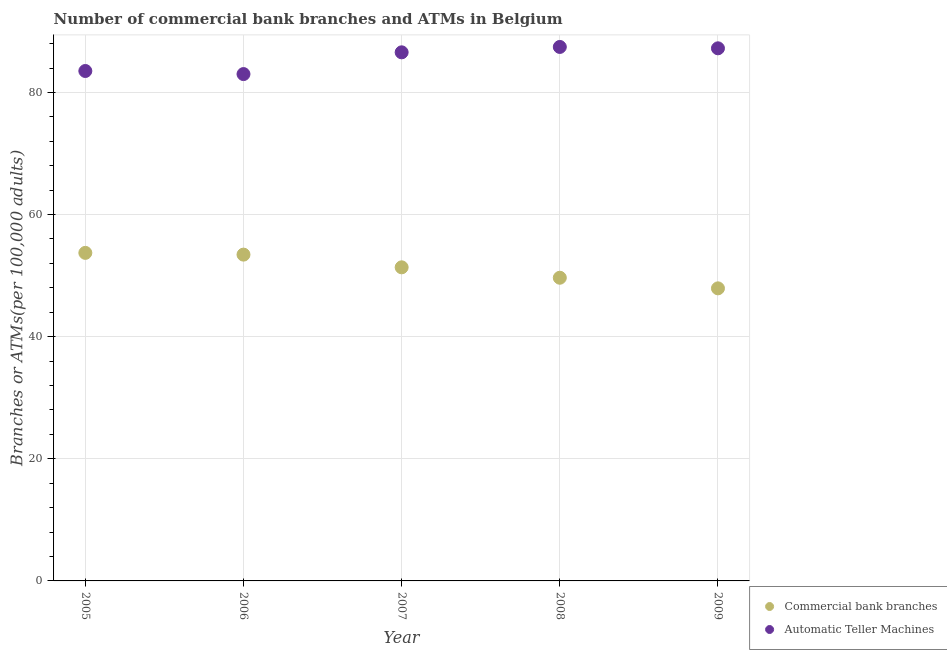How many different coloured dotlines are there?
Give a very brief answer. 2. Is the number of dotlines equal to the number of legend labels?
Your answer should be compact. Yes. What is the number of atms in 2005?
Offer a terse response. 83.51. Across all years, what is the maximum number of atms?
Your answer should be very brief. 87.45. Across all years, what is the minimum number of atms?
Your answer should be very brief. 83.01. In which year was the number of atms maximum?
Offer a terse response. 2008. In which year was the number of atms minimum?
Ensure brevity in your answer.  2006. What is the total number of atms in the graph?
Offer a very short reply. 427.77. What is the difference between the number of atms in 2006 and that in 2009?
Give a very brief answer. -4.22. What is the difference between the number of atms in 2009 and the number of commercal bank branches in 2008?
Give a very brief answer. 37.57. What is the average number of commercal bank branches per year?
Ensure brevity in your answer.  51.22. In the year 2008, what is the difference between the number of atms and number of commercal bank branches?
Provide a short and direct response. 37.8. In how many years, is the number of atms greater than 16?
Offer a terse response. 5. What is the ratio of the number of atms in 2005 to that in 2006?
Give a very brief answer. 1.01. Is the number of atms in 2006 less than that in 2009?
Give a very brief answer. Yes. Is the difference between the number of commercal bank branches in 2007 and 2008 greater than the difference between the number of atms in 2007 and 2008?
Provide a succinct answer. Yes. What is the difference between the highest and the second highest number of commercal bank branches?
Give a very brief answer. 0.29. What is the difference between the highest and the lowest number of commercal bank branches?
Your response must be concise. 5.81. In how many years, is the number of atms greater than the average number of atms taken over all years?
Provide a succinct answer. 3. Is the sum of the number of commercal bank branches in 2006 and 2007 greater than the maximum number of atms across all years?
Ensure brevity in your answer.  Yes. Is the number of atms strictly less than the number of commercal bank branches over the years?
Your answer should be very brief. No. How many dotlines are there?
Ensure brevity in your answer.  2. How many years are there in the graph?
Provide a succinct answer. 5. What is the difference between two consecutive major ticks on the Y-axis?
Provide a succinct answer. 20. Are the values on the major ticks of Y-axis written in scientific E-notation?
Offer a very short reply. No. Where does the legend appear in the graph?
Provide a short and direct response. Bottom right. How many legend labels are there?
Offer a terse response. 2. How are the legend labels stacked?
Your response must be concise. Vertical. What is the title of the graph?
Provide a succinct answer. Number of commercial bank branches and ATMs in Belgium. Does "Savings" appear as one of the legend labels in the graph?
Offer a terse response. No. What is the label or title of the Y-axis?
Your answer should be very brief. Branches or ATMs(per 100,0 adults). What is the Branches or ATMs(per 100,000 adults) of Commercial bank branches in 2005?
Your answer should be very brief. 53.73. What is the Branches or ATMs(per 100,000 adults) of Automatic Teller Machines in 2005?
Offer a very short reply. 83.51. What is the Branches or ATMs(per 100,000 adults) of Commercial bank branches in 2006?
Provide a short and direct response. 53.44. What is the Branches or ATMs(per 100,000 adults) in Automatic Teller Machines in 2006?
Keep it short and to the point. 83.01. What is the Branches or ATMs(per 100,000 adults) in Commercial bank branches in 2007?
Give a very brief answer. 51.36. What is the Branches or ATMs(per 100,000 adults) in Automatic Teller Machines in 2007?
Keep it short and to the point. 86.57. What is the Branches or ATMs(per 100,000 adults) in Commercial bank branches in 2008?
Ensure brevity in your answer.  49.65. What is the Branches or ATMs(per 100,000 adults) in Automatic Teller Machines in 2008?
Your answer should be compact. 87.45. What is the Branches or ATMs(per 100,000 adults) of Commercial bank branches in 2009?
Ensure brevity in your answer.  47.92. What is the Branches or ATMs(per 100,000 adults) in Automatic Teller Machines in 2009?
Offer a terse response. 87.23. Across all years, what is the maximum Branches or ATMs(per 100,000 adults) in Commercial bank branches?
Your answer should be compact. 53.73. Across all years, what is the maximum Branches or ATMs(per 100,000 adults) in Automatic Teller Machines?
Your response must be concise. 87.45. Across all years, what is the minimum Branches or ATMs(per 100,000 adults) in Commercial bank branches?
Ensure brevity in your answer.  47.92. Across all years, what is the minimum Branches or ATMs(per 100,000 adults) of Automatic Teller Machines?
Your answer should be compact. 83.01. What is the total Branches or ATMs(per 100,000 adults) in Commercial bank branches in the graph?
Offer a terse response. 256.1. What is the total Branches or ATMs(per 100,000 adults) of Automatic Teller Machines in the graph?
Your response must be concise. 427.77. What is the difference between the Branches or ATMs(per 100,000 adults) of Commercial bank branches in 2005 and that in 2006?
Your answer should be compact. 0.29. What is the difference between the Branches or ATMs(per 100,000 adults) of Automatic Teller Machines in 2005 and that in 2006?
Give a very brief answer. 0.5. What is the difference between the Branches or ATMs(per 100,000 adults) of Commercial bank branches in 2005 and that in 2007?
Your answer should be compact. 2.37. What is the difference between the Branches or ATMs(per 100,000 adults) in Automatic Teller Machines in 2005 and that in 2007?
Your answer should be very brief. -3.06. What is the difference between the Branches or ATMs(per 100,000 adults) in Commercial bank branches in 2005 and that in 2008?
Make the answer very short. 4.07. What is the difference between the Branches or ATMs(per 100,000 adults) in Automatic Teller Machines in 2005 and that in 2008?
Your answer should be very brief. -3.94. What is the difference between the Branches or ATMs(per 100,000 adults) of Commercial bank branches in 2005 and that in 2009?
Provide a succinct answer. 5.81. What is the difference between the Branches or ATMs(per 100,000 adults) of Automatic Teller Machines in 2005 and that in 2009?
Provide a succinct answer. -3.71. What is the difference between the Branches or ATMs(per 100,000 adults) in Commercial bank branches in 2006 and that in 2007?
Your response must be concise. 2.08. What is the difference between the Branches or ATMs(per 100,000 adults) of Automatic Teller Machines in 2006 and that in 2007?
Provide a short and direct response. -3.56. What is the difference between the Branches or ATMs(per 100,000 adults) in Commercial bank branches in 2006 and that in 2008?
Your answer should be compact. 3.79. What is the difference between the Branches or ATMs(per 100,000 adults) of Automatic Teller Machines in 2006 and that in 2008?
Provide a short and direct response. -4.44. What is the difference between the Branches or ATMs(per 100,000 adults) in Commercial bank branches in 2006 and that in 2009?
Make the answer very short. 5.52. What is the difference between the Branches or ATMs(per 100,000 adults) in Automatic Teller Machines in 2006 and that in 2009?
Keep it short and to the point. -4.22. What is the difference between the Branches or ATMs(per 100,000 adults) of Commercial bank branches in 2007 and that in 2008?
Your response must be concise. 1.71. What is the difference between the Branches or ATMs(per 100,000 adults) in Automatic Teller Machines in 2007 and that in 2008?
Provide a succinct answer. -0.88. What is the difference between the Branches or ATMs(per 100,000 adults) in Commercial bank branches in 2007 and that in 2009?
Provide a succinct answer. 3.44. What is the difference between the Branches or ATMs(per 100,000 adults) in Automatic Teller Machines in 2007 and that in 2009?
Make the answer very short. -0.66. What is the difference between the Branches or ATMs(per 100,000 adults) of Commercial bank branches in 2008 and that in 2009?
Provide a short and direct response. 1.74. What is the difference between the Branches or ATMs(per 100,000 adults) in Automatic Teller Machines in 2008 and that in 2009?
Provide a succinct answer. 0.22. What is the difference between the Branches or ATMs(per 100,000 adults) of Commercial bank branches in 2005 and the Branches or ATMs(per 100,000 adults) of Automatic Teller Machines in 2006?
Your response must be concise. -29.28. What is the difference between the Branches or ATMs(per 100,000 adults) of Commercial bank branches in 2005 and the Branches or ATMs(per 100,000 adults) of Automatic Teller Machines in 2007?
Give a very brief answer. -32.84. What is the difference between the Branches or ATMs(per 100,000 adults) in Commercial bank branches in 2005 and the Branches or ATMs(per 100,000 adults) in Automatic Teller Machines in 2008?
Your response must be concise. -33.73. What is the difference between the Branches or ATMs(per 100,000 adults) in Commercial bank branches in 2005 and the Branches or ATMs(per 100,000 adults) in Automatic Teller Machines in 2009?
Offer a very short reply. -33.5. What is the difference between the Branches or ATMs(per 100,000 adults) of Commercial bank branches in 2006 and the Branches or ATMs(per 100,000 adults) of Automatic Teller Machines in 2007?
Offer a very short reply. -33.13. What is the difference between the Branches or ATMs(per 100,000 adults) of Commercial bank branches in 2006 and the Branches or ATMs(per 100,000 adults) of Automatic Teller Machines in 2008?
Keep it short and to the point. -34.01. What is the difference between the Branches or ATMs(per 100,000 adults) in Commercial bank branches in 2006 and the Branches or ATMs(per 100,000 adults) in Automatic Teller Machines in 2009?
Offer a terse response. -33.79. What is the difference between the Branches or ATMs(per 100,000 adults) in Commercial bank branches in 2007 and the Branches or ATMs(per 100,000 adults) in Automatic Teller Machines in 2008?
Offer a very short reply. -36.09. What is the difference between the Branches or ATMs(per 100,000 adults) in Commercial bank branches in 2007 and the Branches or ATMs(per 100,000 adults) in Automatic Teller Machines in 2009?
Offer a very short reply. -35.87. What is the difference between the Branches or ATMs(per 100,000 adults) in Commercial bank branches in 2008 and the Branches or ATMs(per 100,000 adults) in Automatic Teller Machines in 2009?
Make the answer very short. -37.57. What is the average Branches or ATMs(per 100,000 adults) of Commercial bank branches per year?
Give a very brief answer. 51.22. What is the average Branches or ATMs(per 100,000 adults) in Automatic Teller Machines per year?
Provide a succinct answer. 85.55. In the year 2005, what is the difference between the Branches or ATMs(per 100,000 adults) of Commercial bank branches and Branches or ATMs(per 100,000 adults) of Automatic Teller Machines?
Ensure brevity in your answer.  -29.79. In the year 2006, what is the difference between the Branches or ATMs(per 100,000 adults) in Commercial bank branches and Branches or ATMs(per 100,000 adults) in Automatic Teller Machines?
Make the answer very short. -29.57. In the year 2007, what is the difference between the Branches or ATMs(per 100,000 adults) in Commercial bank branches and Branches or ATMs(per 100,000 adults) in Automatic Teller Machines?
Your answer should be very brief. -35.21. In the year 2008, what is the difference between the Branches or ATMs(per 100,000 adults) in Commercial bank branches and Branches or ATMs(per 100,000 adults) in Automatic Teller Machines?
Keep it short and to the point. -37.8. In the year 2009, what is the difference between the Branches or ATMs(per 100,000 adults) of Commercial bank branches and Branches or ATMs(per 100,000 adults) of Automatic Teller Machines?
Give a very brief answer. -39.31. What is the ratio of the Branches or ATMs(per 100,000 adults) of Commercial bank branches in 2005 to that in 2006?
Offer a terse response. 1.01. What is the ratio of the Branches or ATMs(per 100,000 adults) in Automatic Teller Machines in 2005 to that in 2006?
Your answer should be compact. 1.01. What is the ratio of the Branches or ATMs(per 100,000 adults) of Commercial bank branches in 2005 to that in 2007?
Your answer should be very brief. 1.05. What is the ratio of the Branches or ATMs(per 100,000 adults) in Automatic Teller Machines in 2005 to that in 2007?
Ensure brevity in your answer.  0.96. What is the ratio of the Branches or ATMs(per 100,000 adults) in Commercial bank branches in 2005 to that in 2008?
Keep it short and to the point. 1.08. What is the ratio of the Branches or ATMs(per 100,000 adults) of Automatic Teller Machines in 2005 to that in 2008?
Your answer should be very brief. 0.95. What is the ratio of the Branches or ATMs(per 100,000 adults) in Commercial bank branches in 2005 to that in 2009?
Provide a short and direct response. 1.12. What is the ratio of the Branches or ATMs(per 100,000 adults) of Automatic Teller Machines in 2005 to that in 2009?
Provide a succinct answer. 0.96. What is the ratio of the Branches or ATMs(per 100,000 adults) of Commercial bank branches in 2006 to that in 2007?
Provide a short and direct response. 1.04. What is the ratio of the Branches or ATMs(per 100,000 adults) of Automatic Teller Machines in 2006 to that in 2007?
Give a very brief answer. 0.96. What is the ratio of the Branches or ATMs(per 100,000 adults) in Commercial bank branches in 2006 to that in 2008?
Your answer should be very brief. 1.08. What is the ratio of the Branches or ATMs(per 100,000 adults) in Automatic Teller Machines in 2006 to that in 2008?
Give a very brief answer. 0.95. What is the ratio of the Branches or ATMs(per 100,000 adults) of Commercial bank branches in 2006 to that in 2009?
Offer a very short reply. 1.12. What is the ratio of the Branches or ATMs(per 100,000 adults) of Automatic Teller Machines in 2006 to that in 2009?
Ensure brevity in your answer.  0.95. What is the ratio of the Branches or ATMs(per 100,000 adults) in Commercial bank branches in 2007 to that in 2008?
Give a very brief answer. 1.03. What is the ratio of the Branches or ATMs(per 100,000 adults) in Commercial bank branches in 2007 to that in 2009?
Your answer should be very brief. 1.07. What is the ratio of the Branches or ATMs(per 100,000 adults) in Commercial bank branches in 2008 to that in 2009?
Provide a short and direct response. 1.04. What is the ratio of the Branches or ATMs(per 100,000 adults) in Automatic Teller Machines in 2008 to that in 2009?
Make the answer very short. 1. What is the difference between the highest and the second highest Branches or ATMs(per 100,000 adults) in Commercial bank branches?
Keep it short and to the point. 0.29. What is the difference between the highest and the second highest Branches or ATMs(per 100,000 adults) of Automatic Teller Machines?
Your answer should be compact. 0.22. What is the difference between the highest and the lowest Branches or ATMs(per 100,000 adults) in Commercial bank branches?
Offer a very short reply. 5.81. What is the difference between the highest and the lowest Branches or ATMs(per 100,000 adults) in Automatic Teller Machines?
Your response must be concise. 4.44. 